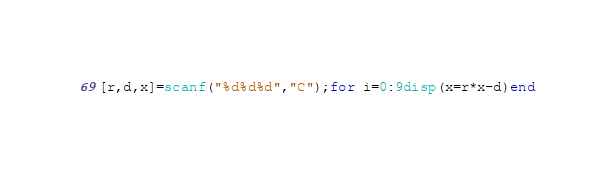Convert code to text. <code><loc_0><loc_0><loc_500><loc_500><_Octave_>[r,d,x]=scanf("%d%d%d","C");for i=0:9disp(x=r*x-d)end</code> 